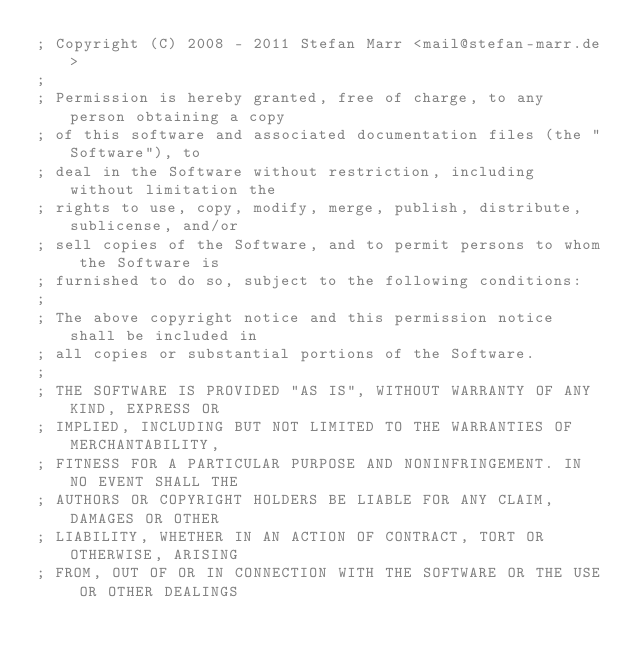<code> <loc_0><loc_0><loc_500><loc_500><_Clojure_>; Copyright (C) 2008 - 2011 Stefan Marr <mail@stefan-marr.de>
; 
; Permission is hereby granted, free of charge, to any person obtaining a copy
; of this software and associated documentation files (the "Software"), to
; deal in the Software without restriction, including without limitation the
; rights to use, copy, modify, merge, publish, distribute, sublicense, and/or
; sell copies of the Software, and to permit persons to whom the Software is
; furnished to do so, subject to the following conditions:
; 
; The above copyright notice and this permission notice shall be included in
; all copies or substantial portions of the Software.
; 
; THE SOFTWARE IS PROVIDED "AS IS", WITHOUT WARRANTY OF ANY KIND, EXPRESS OR
; IMPLIED, INCLUDING BUT NOT LIMITED TO THE WARRANTIES OF MERCHANTABILITY,
; FITNESS FOR A PARTICULAR PURPOSE AND NONINFRINGEMENT. IN NO EVENT SHALL THE
; AUTHORS OR COPYRIGHT HOLDERS BE LIABLE FOR ANY CLAIM, DAMAGES OR OTHER
; LIABILITY, WHETHER IN AN ACTION OF CONTRACT, TORT OR OTHERWISE, ARISING
; FROM, OUT OF OR IN CONNECTION WITH THE SOFTWARE OR THE USE OR OTHER DEALINGS</code> 